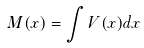<formula> <loc_0><loc_0><loc_500><loc_500>M ( x ) = \int V ( x ) d x</formula> 